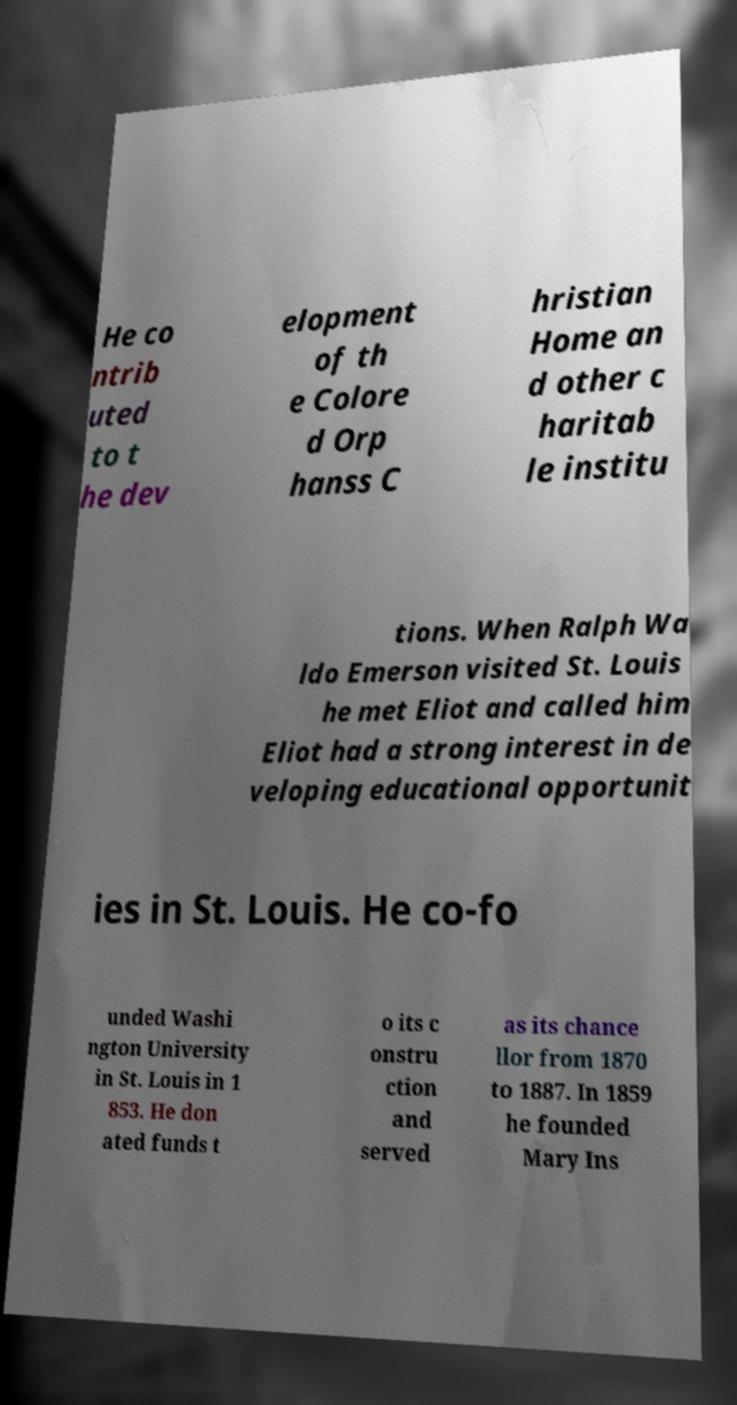Please read and relay the text visible in this image. What does it say? He co ntrib uted to t he dev elopment of th e Colore d Orp hanss C hristian Home an d other c haritab le institu tions. When Ralph Wa ldo Emerson visited St. Louis he met Eliot and called him Eliot had a strong interest in de veloping educational opportunit ies in St. Louis. He co-fo unded Washi ngton University in St. Louis in 1 853. He don ated funds t o its c onstru ction and served as its chance llor from 1870 to 1887. In 1859 he founded Mary Ins 